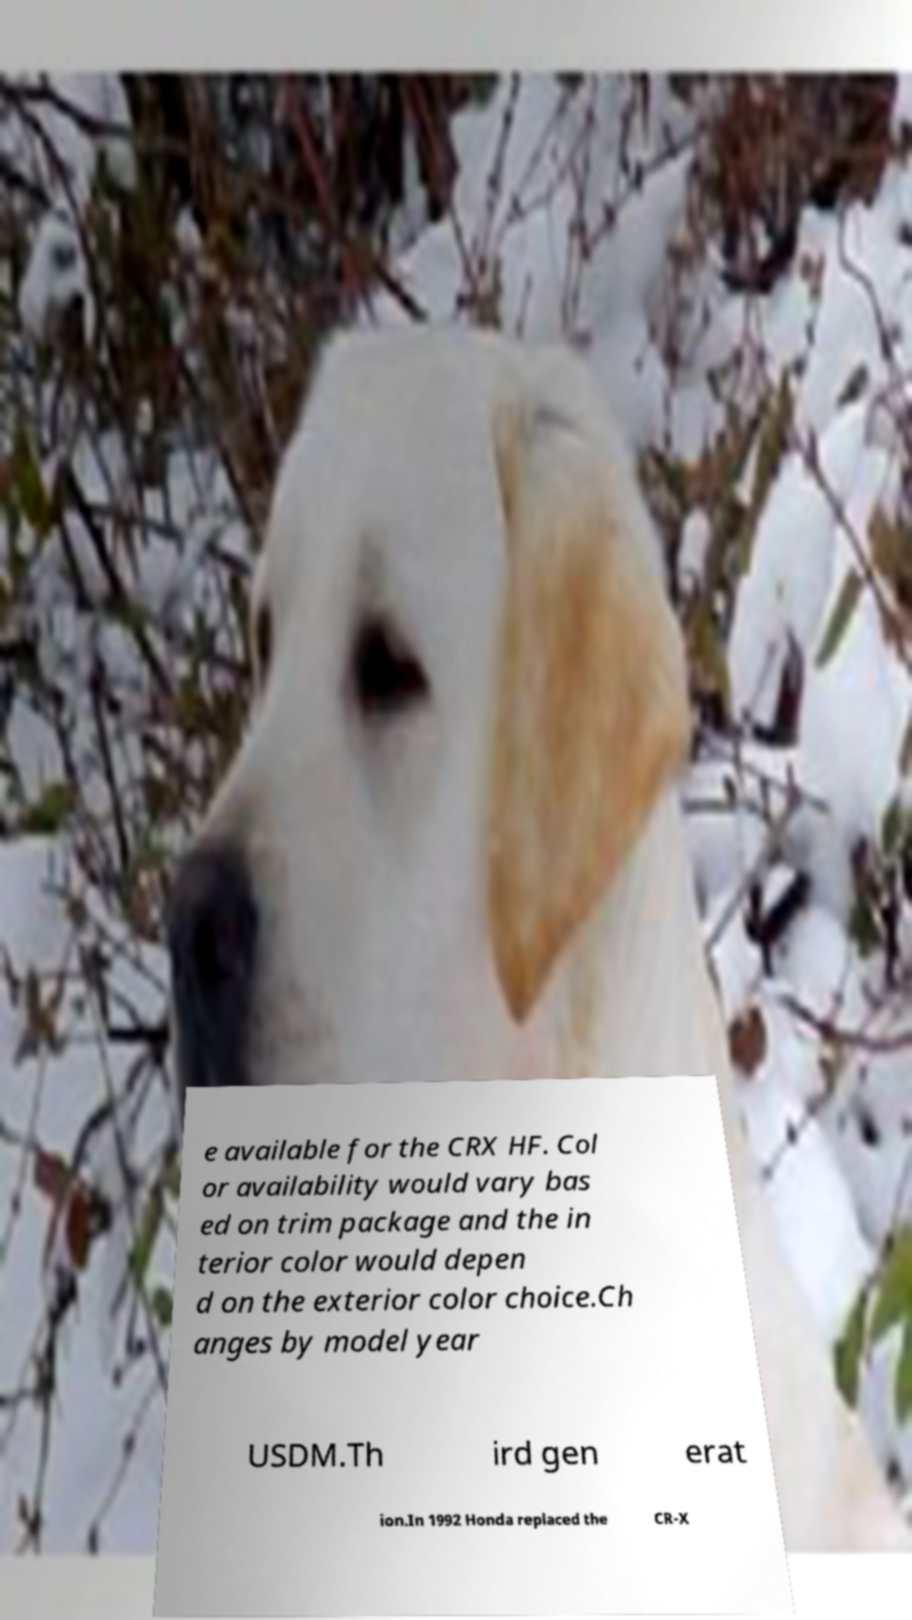Please identify and transcribe the text found in this image. e available for the CRX HF. Col or availability would vary bas ed on trim package and the in terior color would depen d on the exterior color choice.Ch anges by model year USDM.Th ird gen erat ion.In 1992 Honda replaced the CR-X 